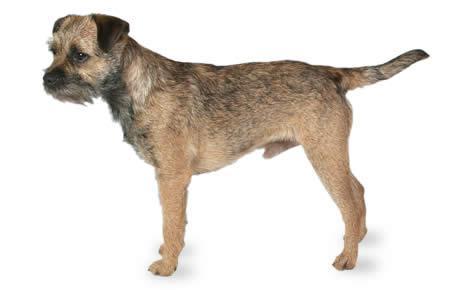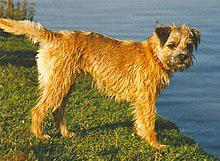The first image is the image on the left, the second image is the image on the right. Considering the images on both sides, is "The dog on the right is standing on grass, but the dog on the left is not standing." valid? Answer yes or no. No. The first image is the image on the left, the second image is the image on the right. Analyze the images presented: Is the assertion "The right image contains exactly one dog standing on grass facing towards the right." valid? Answer yes or no. Yes. 